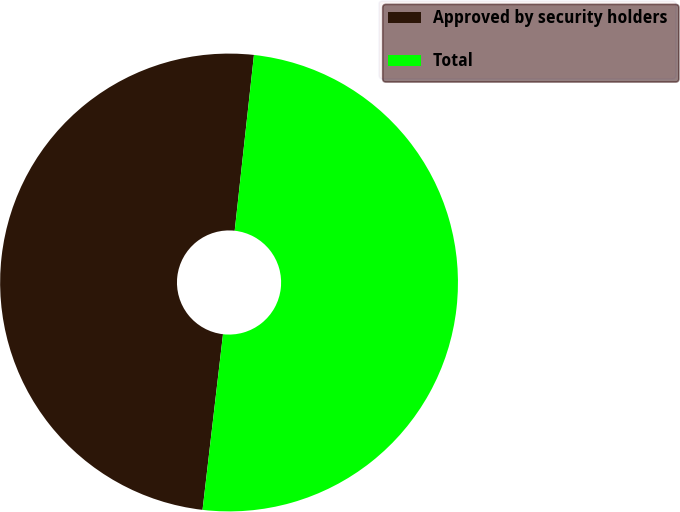<chart> <loc_0><loc_0><loc_500><loc_500><pie_chart><fcel>Approved by security holders<fcel>Total<nl><fcel>49.89%<fcel>50.11%<nl></chart> 